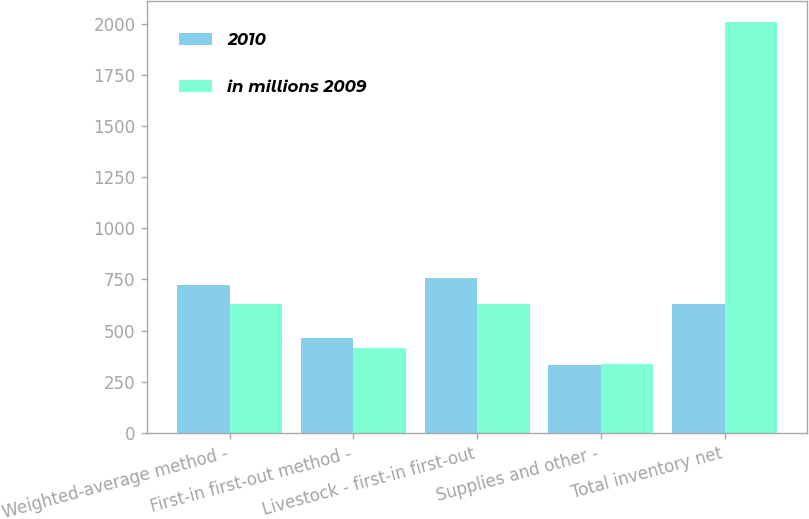Convert chart to OTSL. <chart><loc_0><loc_0><loc_500><loc_500><stacked_bar_chart><ecel><fcel>Weighted-average method -<fcel>First-in first-out method -<fcel>Livestock - first-in first-out<fcel>Supplies and other -<fcel>Total inventory net<nl><fcel>2010<fcel>721<fcel>462<fcel>759<fcel>332<fcel>629<nl><fcel>in millions 2009<fcel>629<fcel>414<fcel>631<fcel>335<fcel>2009<nl></chart> 